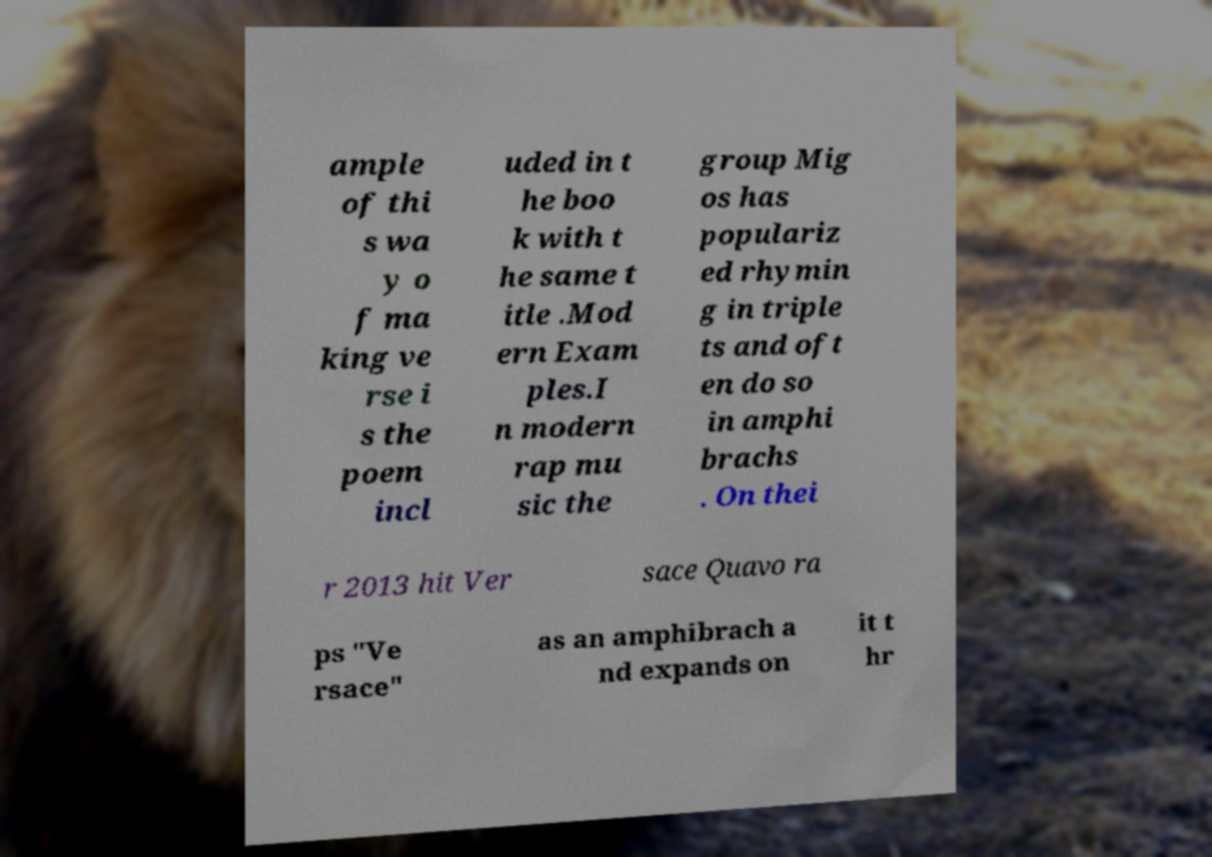There's text embedded in this image that I need extracted. Can you transcribe it verbatim? ample of thi s wa y o f ma king ve rse i s the poem incl uded in t he boo k with t he same t itle .Mod ern Exam ples.I n modern rap mu sic the group Mig os has populariz ed rhymin g in triple ts and oft en do so in amphi brachs . On thei r 2013 hit Ver sace Quavo ra ps "Ve rsace" as an amphibrach a nd expands on it t hr 